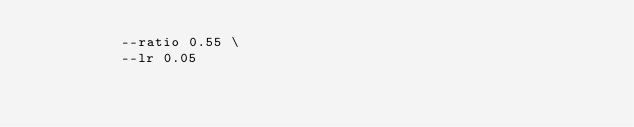Convert code to text. <code><loc_0><loc_0><loc_500><loc_500><_Bash_>          --ratio 0.55 \
          --lr 0.05
</code> 